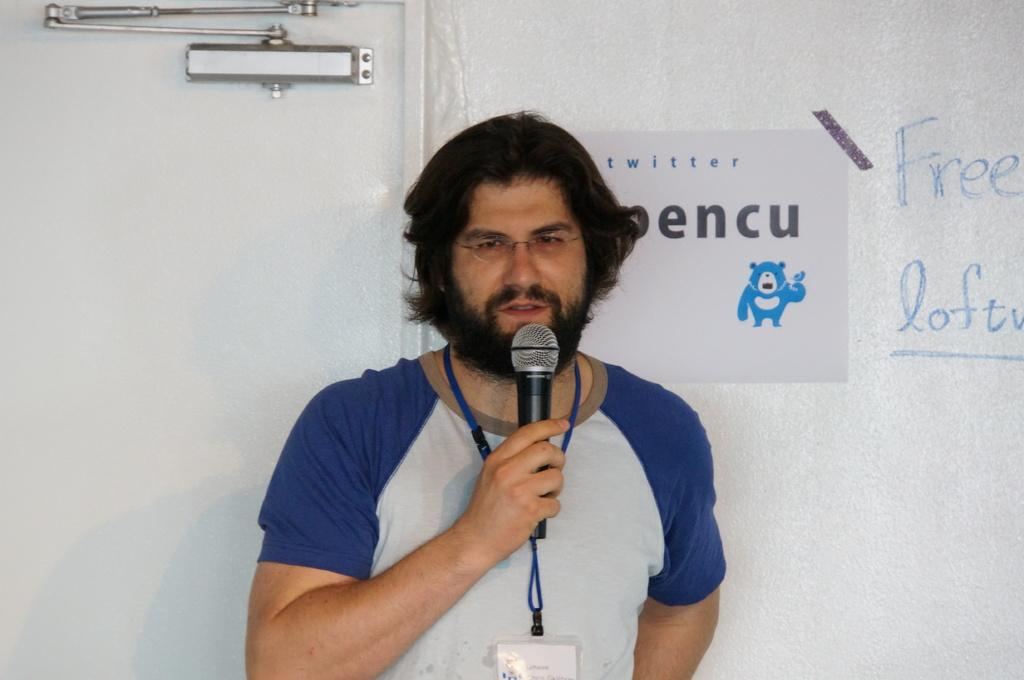What is the man in the image doing? The man is standing in the image and holding a microphone in his hand. What can be seen in the background of the image? There is a door and a poster on the wall in the background. Is there any text visible in the image? Yes, there is text written on the wall in the background. What type of turkey can be seen on the roof in the image? There is no turkey or roof present in the image. 